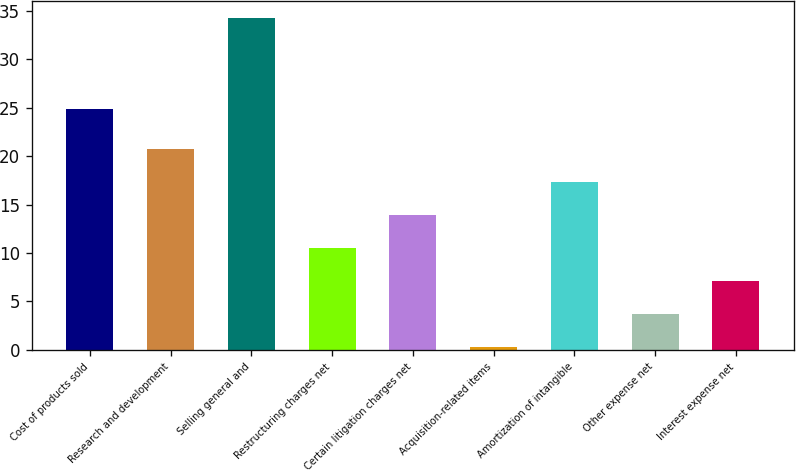<chart> <loc_0><loc_0><loc_500><loc_500><bar_chart><fcel>Cost of products sold<fcel>Research and development<fcel>Selling general and<fcel>Restructuring charges net<fcel>Certain litigation charges net<fcel>Acquisition-related items<fcel>Amortization of intangible<fcel>Other expense net<fcel>Interest expense net<nl><fcel>24.9<fcel>20.7<fcel>34.3<fcel>10.5<fcel>13.9<fcel>0.3<fcel>17.3<fcel>3.7<fcel>7.1<nl></chart> 